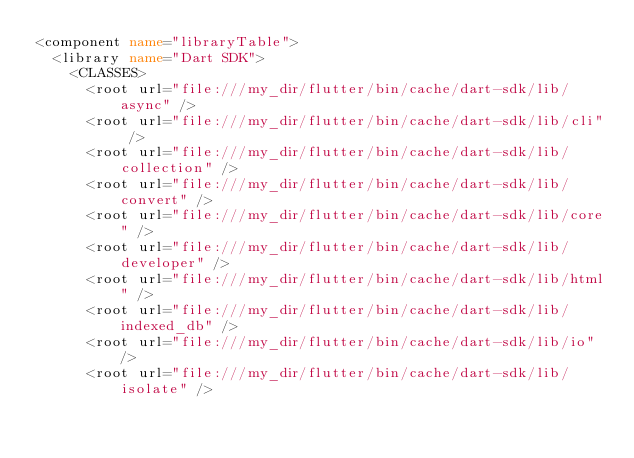Convert code to text. <code><loc_0><loc_0><loc_500><loc_500><_XML_><component name="libraryTable">
  <library name="Dart SDK">
    <CLASSES>
      <root url="file:///my_dir/flutter/bin/cache/dart-sdk/lib/async" />
      <root url="file:///my_dir/flutter/bin/cache/dart-sdk/lib/cli" />
      <root url="file:///my_dir/flutter/bin/cache/dart-sdk/lib/collection" />
      <root url="file:///my_dir/flutter/bin/cache/dart-sdk/lib/convert" />
      <root url="file:///my_dir/flutter/bin/cache/dart-sdk/lib/core" />
      <root url="file:///my_dir/flutter/bin/cache/dart-sdk/lib/developer" />
      <root url="file:///my_dir/flutter/bin/cache/dart-sdk/lib/html" />
      <root url="file:///my_dir/flutter/bin/cache/dart-sdk/lib/indexed_db" />
      <root url="file:///my_dir/flutter/bin/cache/dart-sdk/lib/io" />
      <root url="file:///my_dir/flutter/bin/cache/dart-sdk/lib/isolate" /></code> 